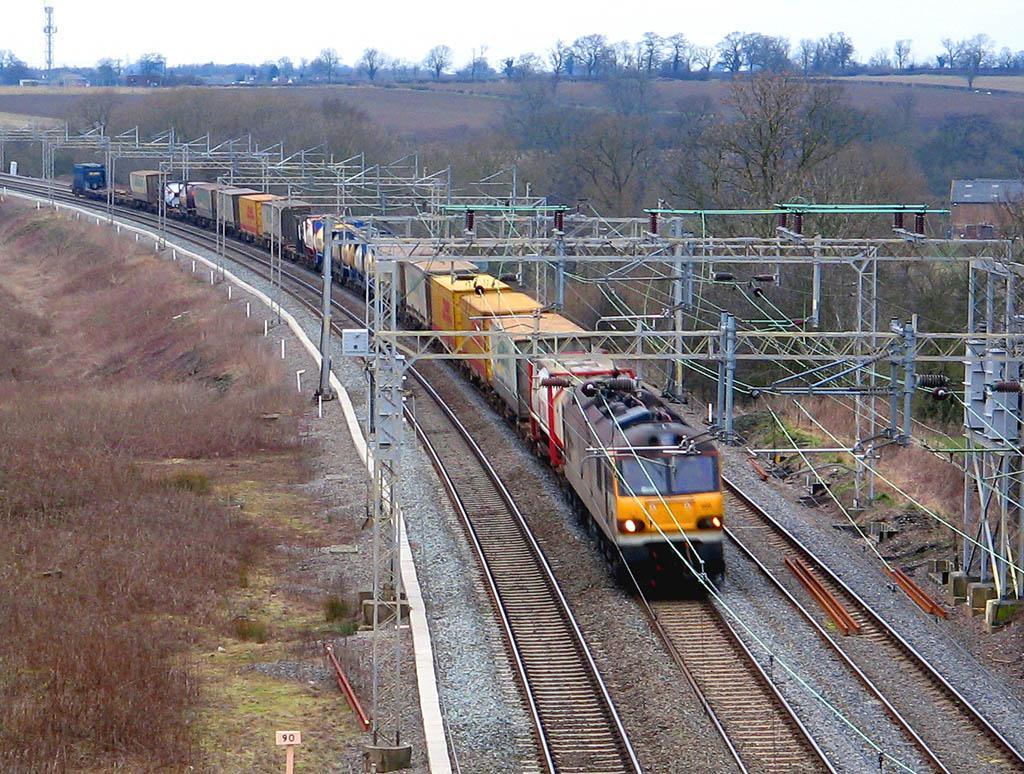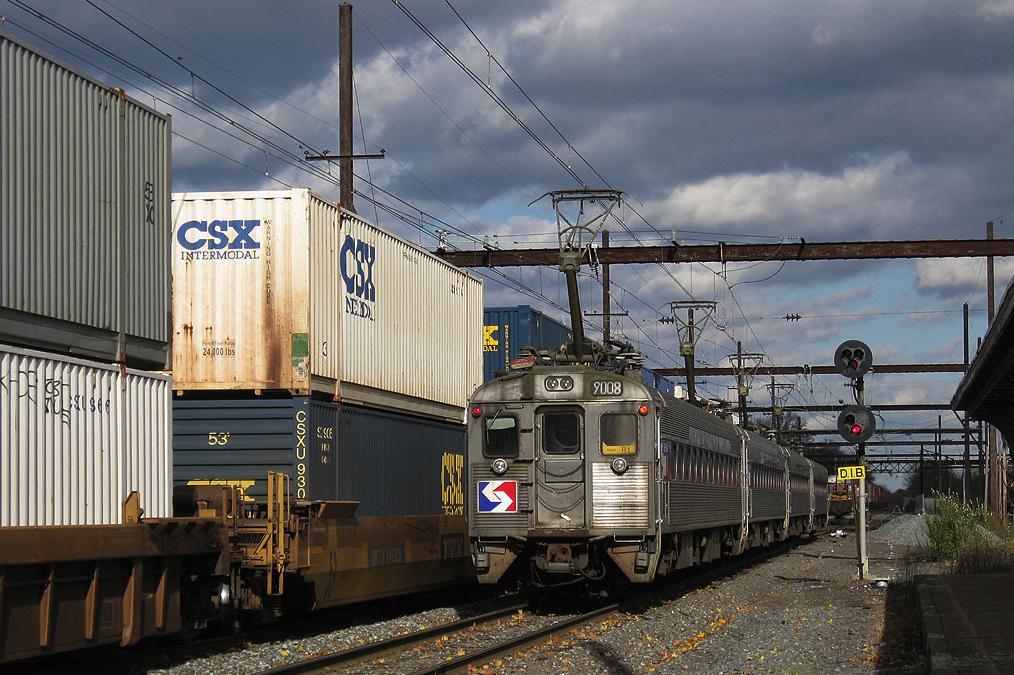The first image is the image on the left, the second image is the image on the right. For the images shown, is this caption "A predominantly yellow train is traveling slightly towards the right." true? Answer yes or no. Yes. 